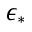<formula> <loc_0><loc_0><loc_500><loc_500>\epsilon _ { * }</formula> 